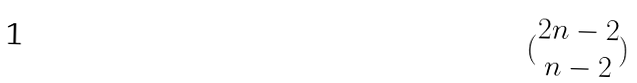<formula> <loc_0><loc_0><loc_500><loc_500>( \begin{matrix} 2 n - 2 \\ n - 2 \end{matrix} )</formula> 